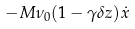<formula> <loc_0><loc_0><loc_500><loc_500>- M \nu _ { 0 } ( 1 - \gamma \delta z ) { \dot { x } }</formula> 